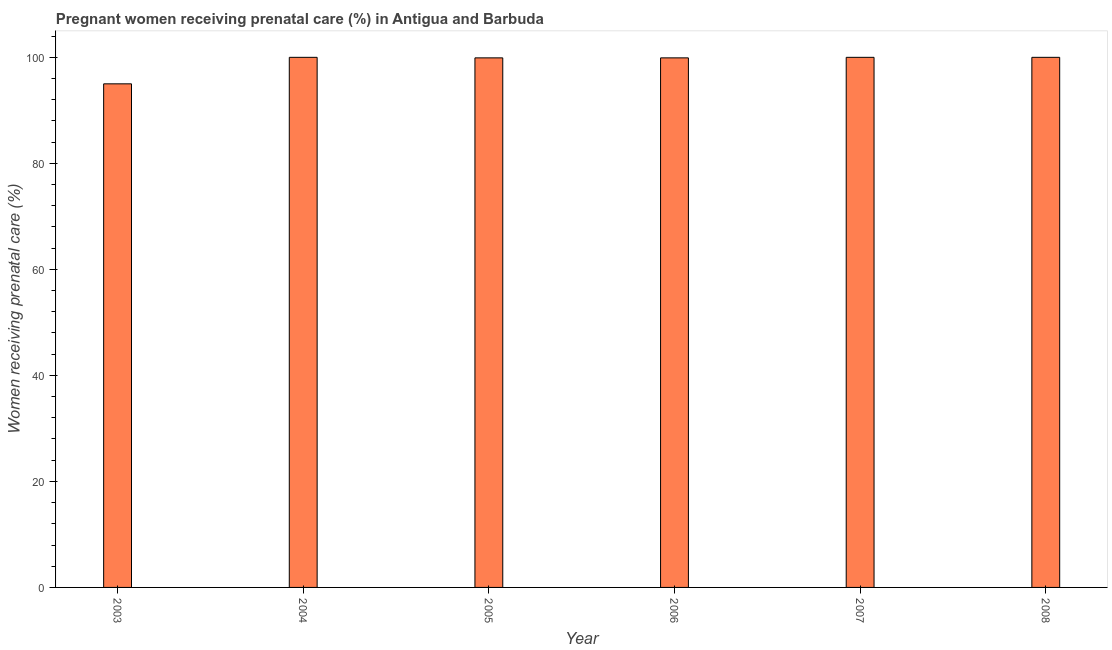Does the graph contain grids?
Your response must be concise. No. What is the title of the graph?
Make the answer very short. Pregnant women receiving prenatal care (%) in Antigua and Barbuda. What is the label or title of the X-axis?
Your response must be concise. Year. What is the label or title of the Y-axis?
Your response must be concise. Women receiving prenatal care (%). What is the percentage of pregnant women receiving prenatal care in 2006?
Your answer should be very brief. 99.9. Across all years, what is the maximum percentage of pregnant women receiving prenatal care?
Make the answer very short. 100. Across all years, what is the minimum percentage of pregnant women receiving prenatal care?
Your answer should be compact. 95. What is the sum of the percentage of pregnant women receiving prenatal care?
Offer a very short reply. 594.8. What is the average percentage of pregnant women receiving prenatal care per year?
Provide a succinct answer. 99.13. What is the median percentage of pregnant women receiving prenatal care?
Provide a succinct answer. 99.95. In how many years, is the percentage of pregnant women receiving prenatal care greater than 40 %?
Your answer should be very brief. 6. Do a majority of the years between 2008 and 2006 (inclusive) have percentage of pregnant women receiving prenatal care greater than 48 %?
Make the answer very short. Yes. What is the ratio of the percentage of pregnant women receiving prenatal care in 2005 to that in 2007?
Your answer should be compact. 1. Is the percentage of pregnant women receiving prenatal care in 2004 less than that in 2005?
Give a very brief answer. No. Is the sum of the percentage of pregnant women receiving prenatal care in 2004 and 2005 greater than the maximum percentage of pregnant women receiving prenatal care across all years?
Your answer should be compact. Yes. What is the difference between the highest and the lowest percentage of pregnant women receiving prenatal care?
Make the answer very short. 5. In how many years, is the percentage of pregnant women receiving prenatal care greater than the average percentage of pregnant women receiving prenatal care taken over all years?
Keep it short and to the point. 5. What is the difference between two consecutive major ticks on the Y-axis?
Provide a short and direct response. 20. Are the values on the major ticks of Y-axis written in scientific E-notation?
Your answer should be compact. No. What is the Women receiving prenatal care (%) of 2003?
Your answer should be very brief. 95. What is the Women receiving prenatal care (%) in 2004?
Keep it short and to the point. 100. What is the Women receiving prenatal care (%) in 2005?
Offer a terse response. 99.9. What is the Women receiving prenatal care (%) in 2006?
Your response must be concise. 99.9. What is the Women receiving prenatal care (%) in 2007?
Your response must be concise. 100. What is the difference between the Women receiving prenatal care (%) in 2003 and 2006?
Ensure brevity in your answer.  -4.9. What is the difference between the Women receiving prenatal care (%) in 2003 and 2008?
Your answer should be compact. -5. What is the difference between the Women receiving prenatal care (%) in 2004 and 2005?
Offer a terse response. 0.1. What is the difference between the Women receiving prenatal care (%) in 2004 and 2006?
Make the answer very short. 0.1. What is the difference between the Women receiving prenatal care (%) in 2004 and 2007?
Provide a succinct answer. 0. What is the difference between the Women receiving prenatal care (%) in 2005 and 2006?
Make the answer very short. 0. What is the difference between the Women receiving prenatal care (%) in 2005 and 2008?
Give a very brief answer. -0.1. What is the difference between the Women receiving prenatal care (%) in 2006 and 2008?
Ensure brevity in your answer.  -0.1. What is the difference between the Women receiving prenatal care (%) in 2007 and 2008?
Your response must be concise. 0. What is the ratio of the Women receiving prenatal care (%) in 2003 to that in 2004?
Your answer should be compact. 0.95. What is the ratio of the Women receiving prenatal care (%) in 2003 to that in 2005?
Offer a very short reply. 0.95. What is the ratio of the Women receiving prenatal care (%) in 2003 to that in 2006?
Provide a succinct answer. 0.95. What is the ratio of the Women receiving prenatal care (%) in 2003 to that in 2008?
Your response must be concise. 0.95. What is the ratio of the Women receiving prenatal care (%) in 2004 to that in 2006?
Ensure brevity in your answer.  1. What is the ratio of the Women receiving prenatal care (%) in 2005 to that in 2006?
Your answer should be very brief. 1. What is the ratio of the Women receiving prenatal care (%) in 2005 to that in 2008?
Give a very brief answer. 1. 